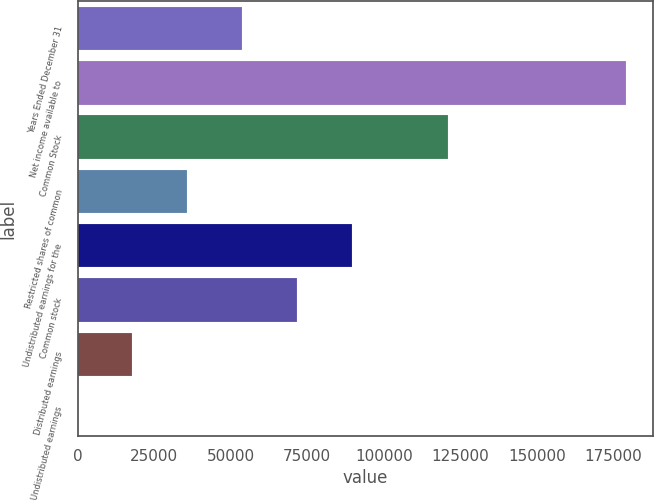Convert chart. <chart><loc_0><loc_0><loc_500><loc_500><bar_chart><fcel>Years Ended December 31<fcel>Net income available to<fcel>Common Stock<fcel>Restricted shares of common<fcel>Undistributed earnings for the<fcel>Common stock<fcel>Distributed earnings<fcel>Undistributed earnings<nl><fcel>53737.4<fcel>179124<fcel>120930<fcel>35825<fcel>89562.1<fcel>71649.7<fcel>17912.6<fcel>0.26<nl></chart> 